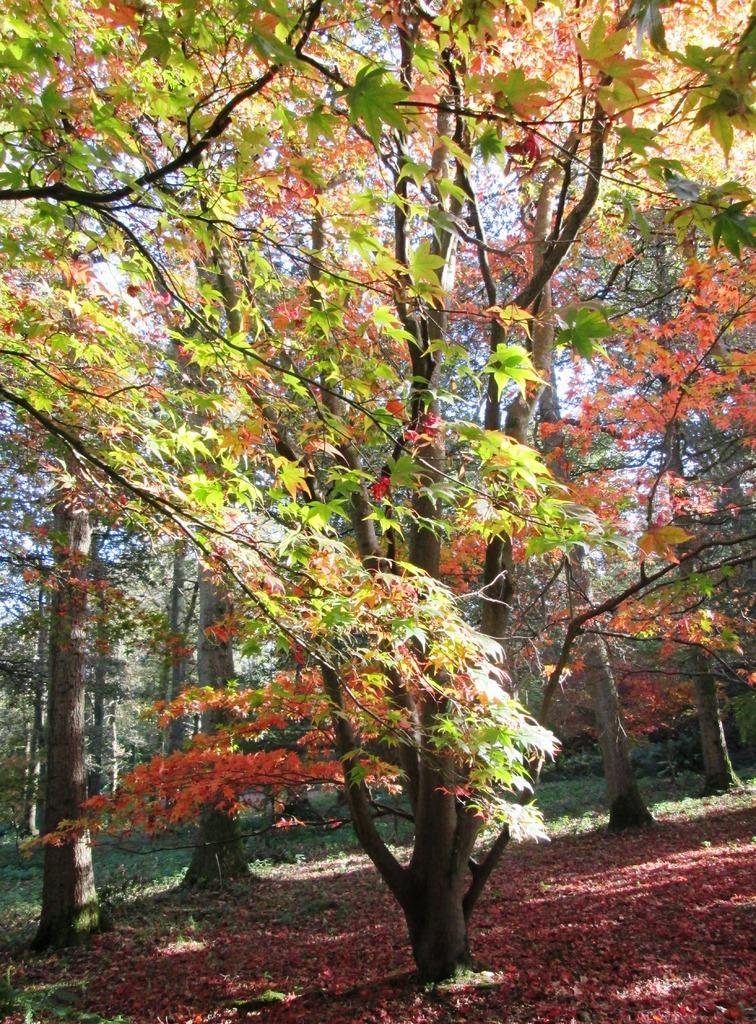Can you describe this image briefly? In this image, we can see trees, plants and grass. In the background, there is the sky. 